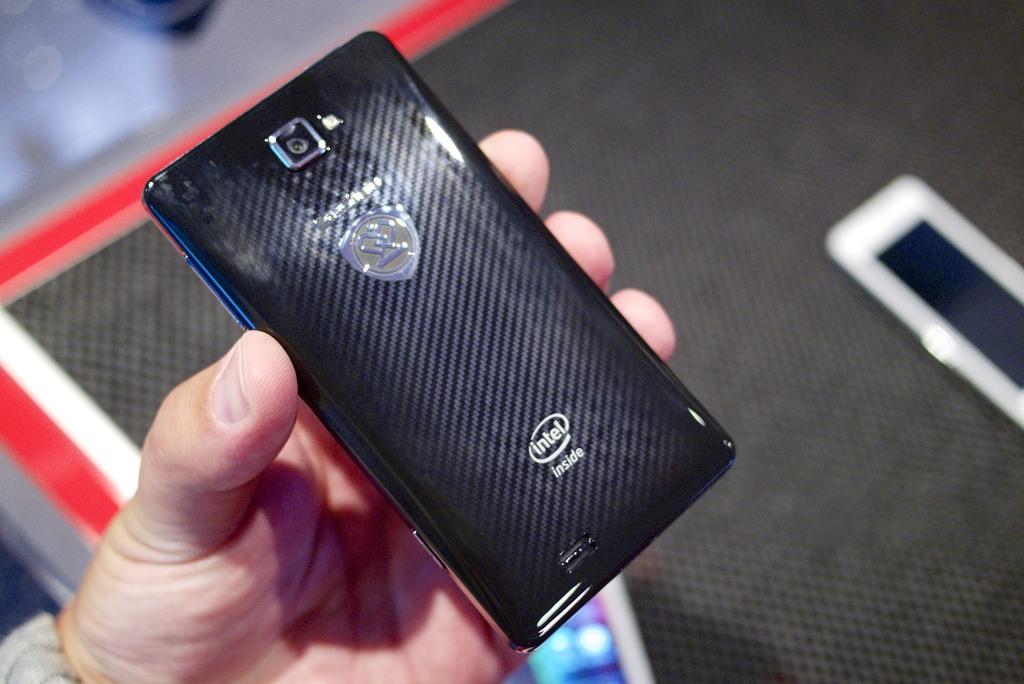What brand is featured on the phone?
Your response must be concise. Intel. What is the brand's tag line?
Provide a succinct answer. Intel inside. 